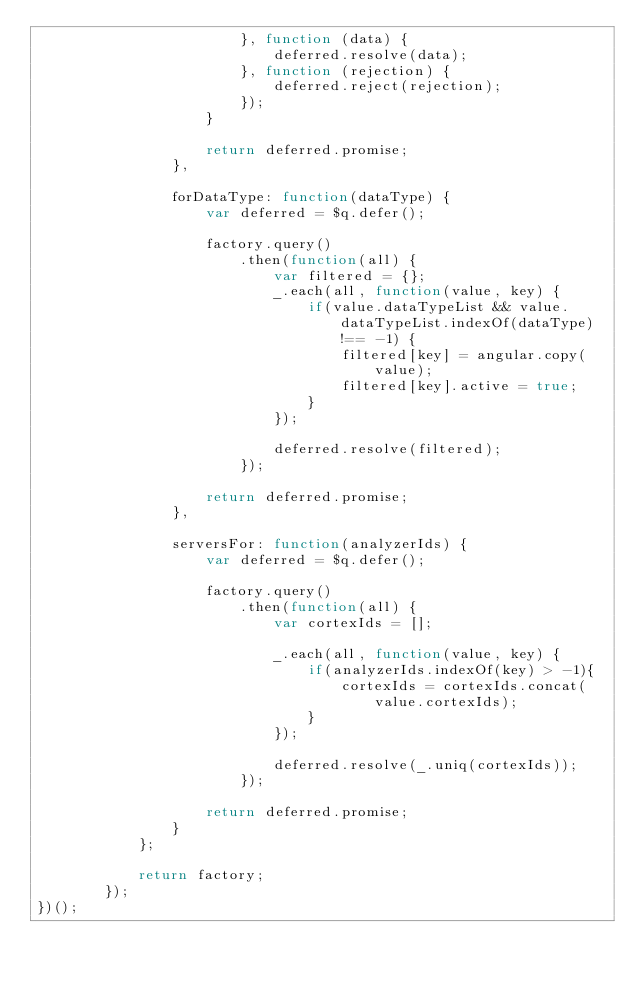Convert code to text. <code><loc_0><loc_0><loc_500><loc_500><_JavaScript_>                        }, function (data) {
                            deferred.resolve(data);
                        }, function (rejection) {
                            deferred.reject(rejection);
                        });
                    }

                    return deferred.promise;
                },

                forDataType: function(dataType) {
                    var deferred = $q.defer();

                    factory.query()
                        .then(function(all) {
                            var filtered = {};
                            _.each(all, function(value, key) {
                                if(value.dataTypeList && value.dataTypeList.indexOf(dataType) !== -1) {
                                    filtered[key] = angular.copy(value);
                                    filtered[key].active = true;
                                }
                            });

                            deferred.resolve(filtered);
                        });

                    return deferred.promise;
                },

                serversFor: function(analyzerIds) {
                    var deferred = $q.defer();

                    factory.query()
                        .then(function(all) {
                            var cortexIds = [];

                            _.each(all, function(value, key) {
                                if(analyzerIds.indexOf(key) > -1){
                                    cortexIds = cortexIds.concat(value.cortexIds);
                                }
                            });

                            deferred.resolve(_.uniq(cortexIds));
                        });

                    return deferred.promise;
                }
            };

            return factory;
        });
})();
</code> 